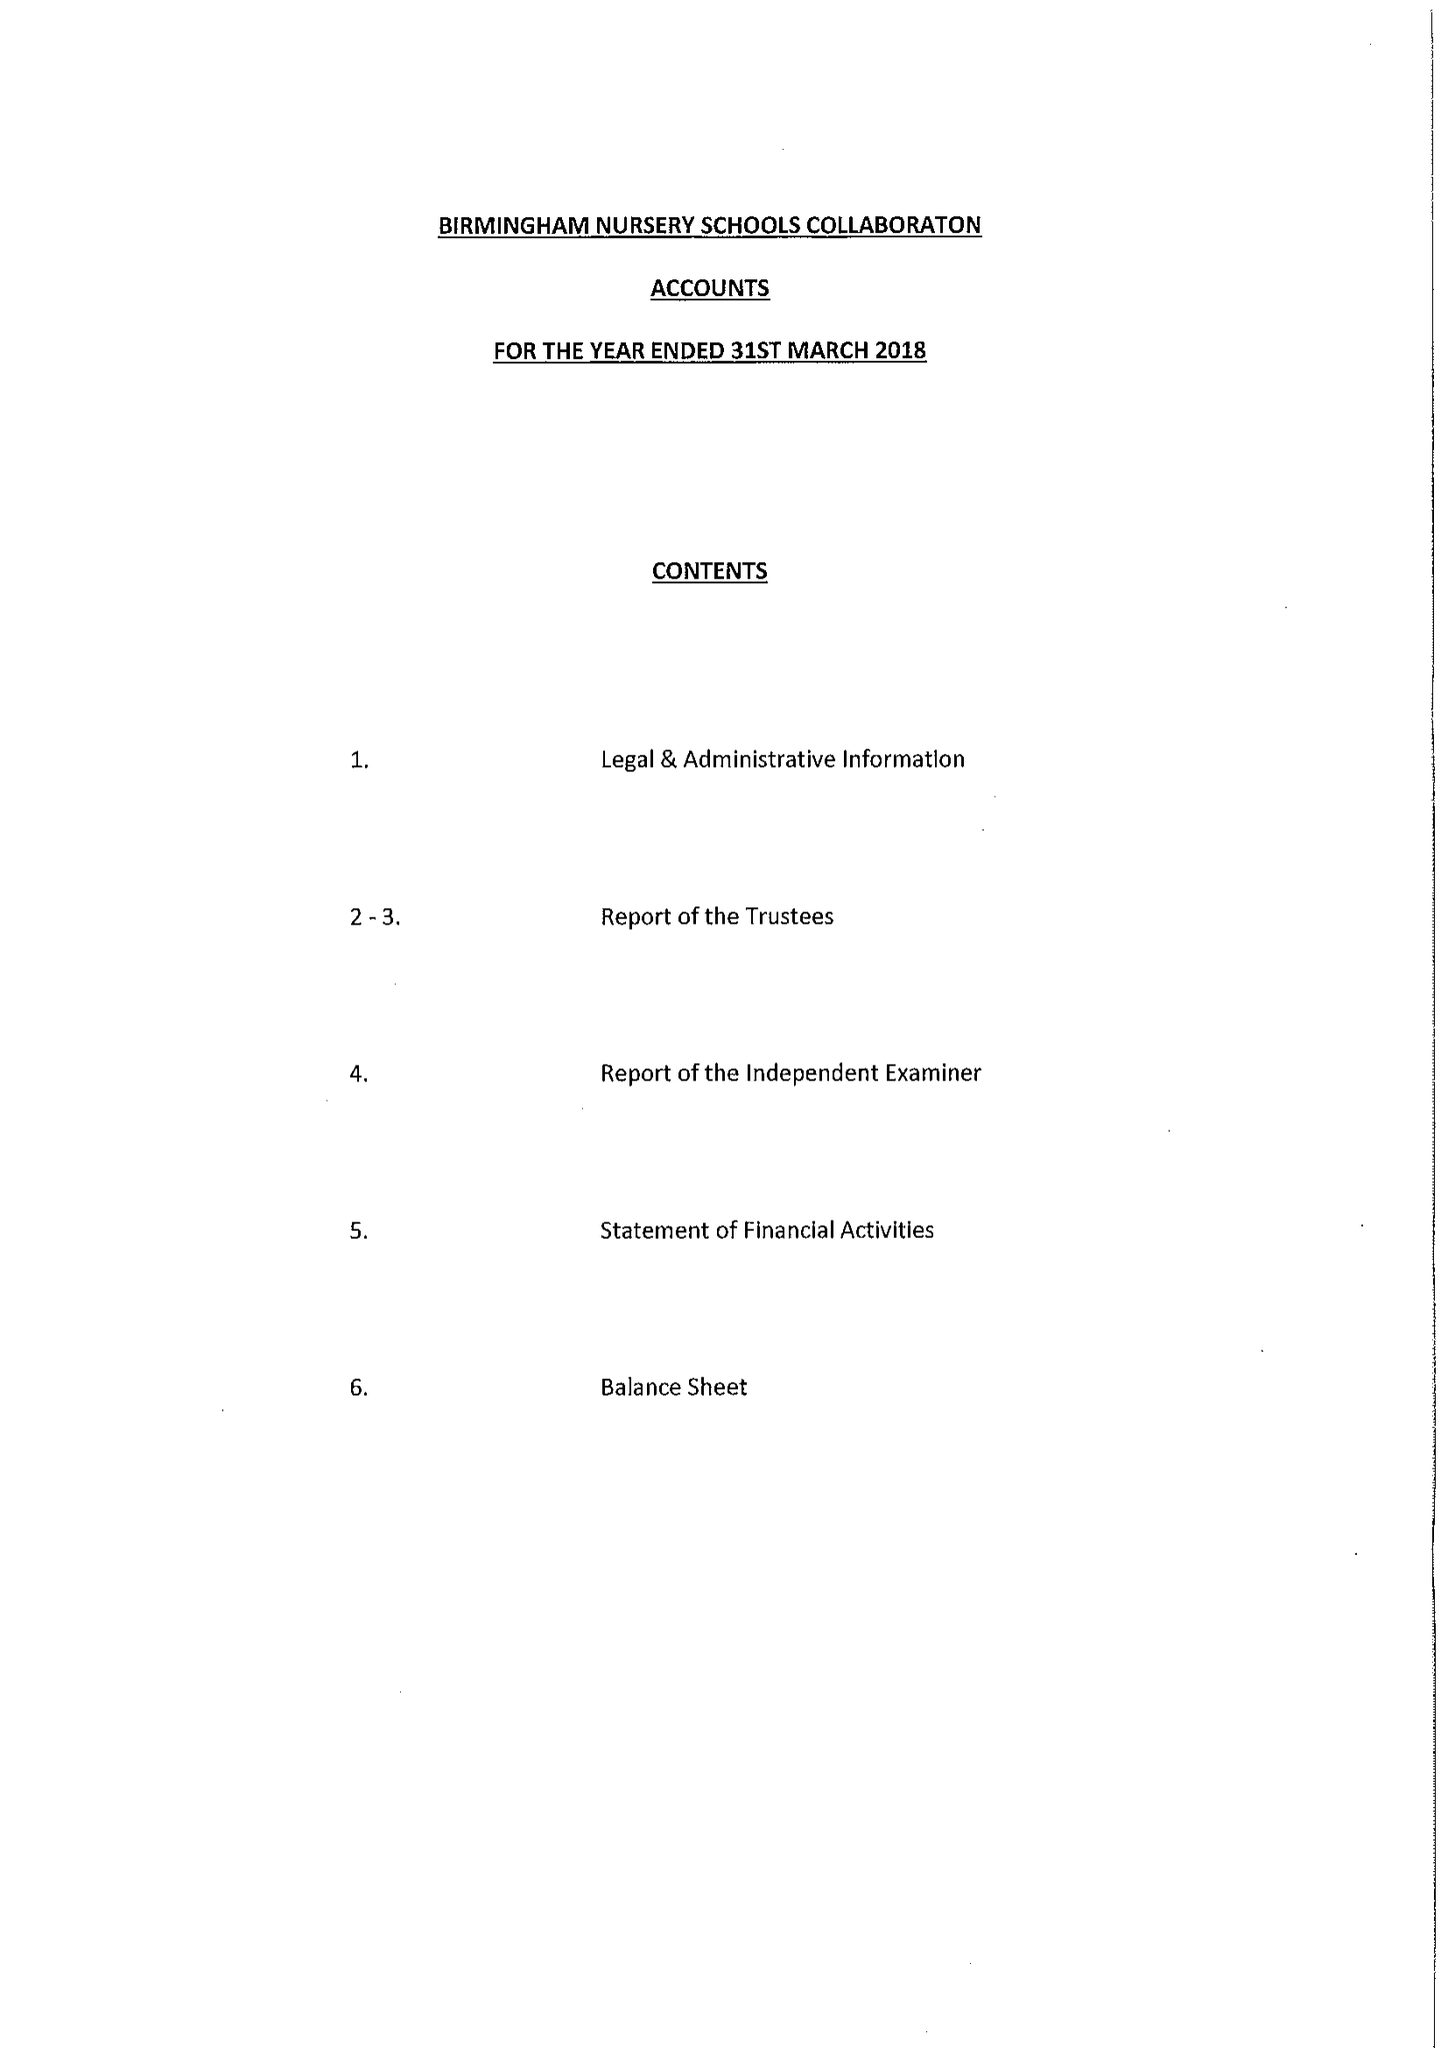What is the value for the charity_number?
Answer the question using a single word or phrase. 1164133 